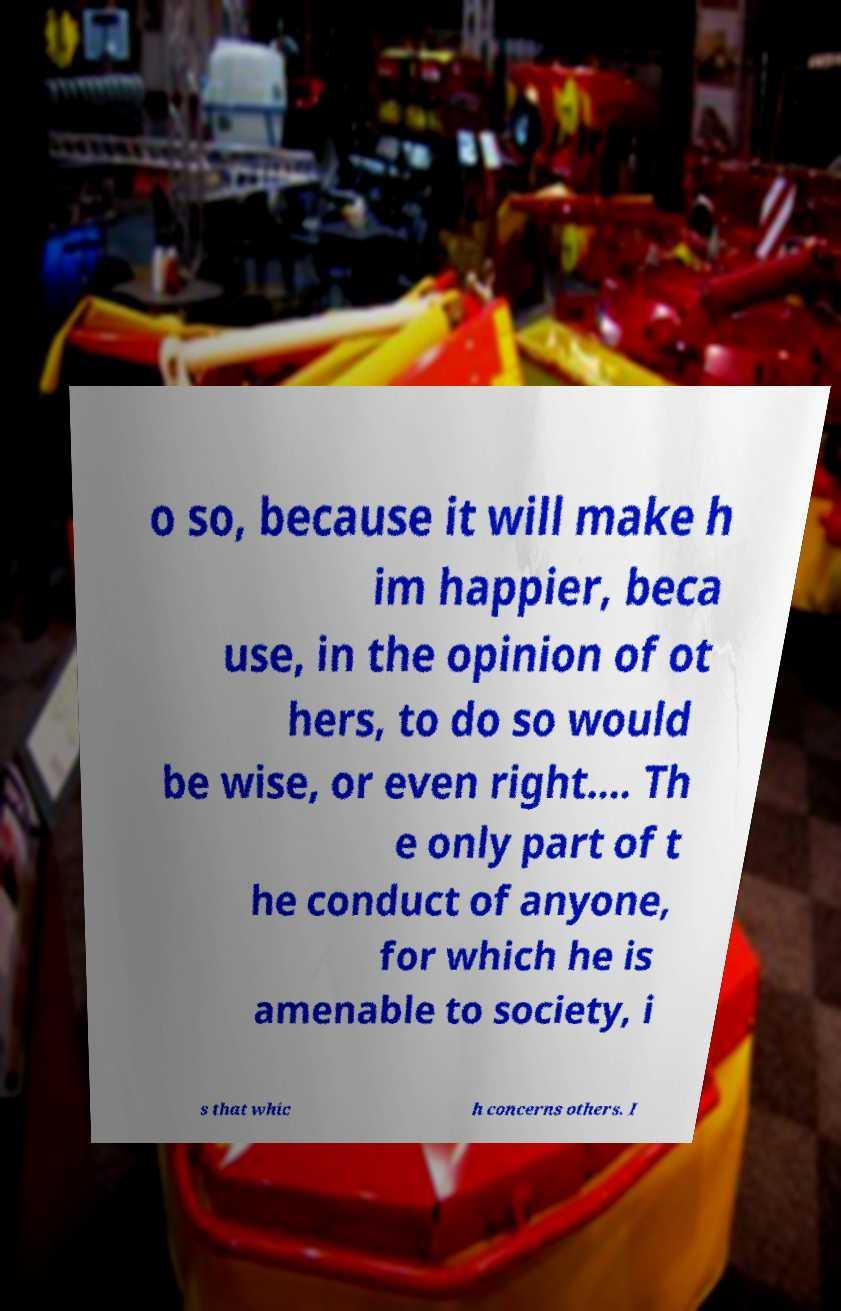Can you accurately transcribe the text from the provided image for me? o so, because it will make h im happier, beca use, in the opinion of ot hers, to do so would be wise, or even right.… Th e only part of t he conduct of anyone, for which he is amenable to society, i s that whic h concerns others. I 